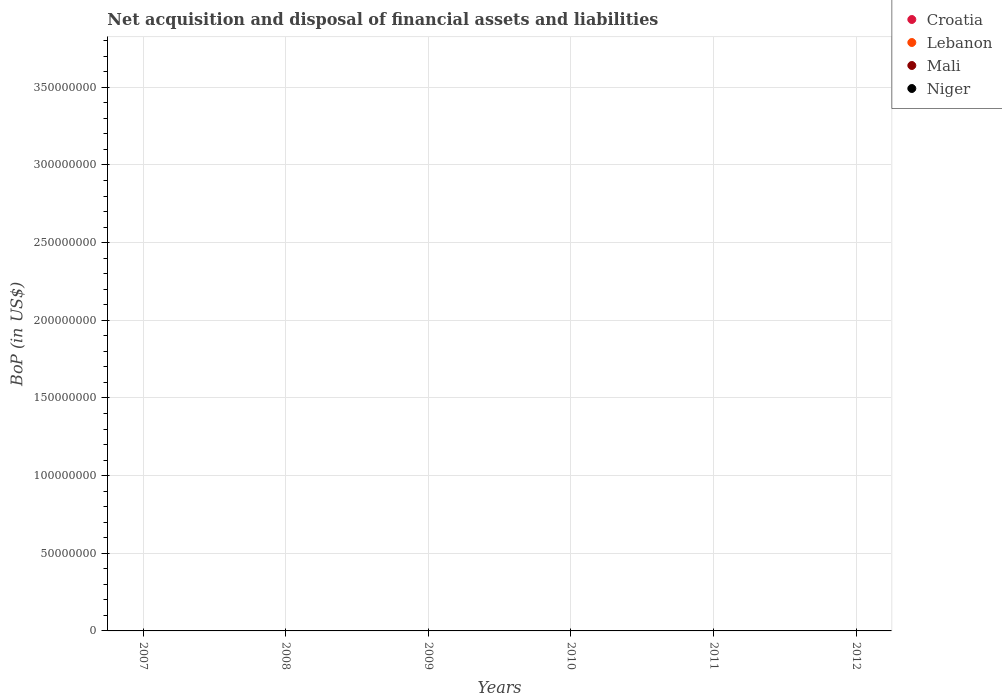How many different coloured dotlines are there?
Offer a very short reply. 0. What is the Balance of Payments in Niger in 2012?
Your answer should be compact. 0. What is the difference between the Balance of Payments in Lebanon in 2011 and the Balance of Payments in Mali in 2010?
Ensure brevity in your answer.  0. What is the average Balance of Payments in Croatia per year?
Your response must be concise. 0. Is it the case that in every year, the sum of the Balance of Payments in Croatia and Balance of Payments in Lebanon  is greater than the Balance of Payments in Niger?
Your answer should be very brief. No. Is the Balance of Payments in Mali strictly greater than the Balance of Payments in Niger over the years?
Your response must be concise. No. Are the values on the major ticks of Y-axis written in scientific E-notation?
Ensure brevity in your answer.  No. Does the graph contain grids?
Offer a very short reply. Yes. How are the legend labels stacked?
Your response must be concise. Vertical. What is the title of the graph?
Make the answer very short. Net acquisition and disposal of financial assets and liabilities. Does "Dominica" appear as one of the legend labels in the graph?
Offer a very short reply. No. What is the label or title of the X-axis?
Your answer should be compact. Years. What is the label or title of the Y-axis?
Keep it short and to the point. BoP (in US$). What is the BoP (in US$) in Croatia in 2007?
Make the answer very short. 0. What is the BoP (in US$) of Lebanon in 2008?
Your answer should be compact. 0. What is the BoP (in US$) of Croatia in 2009?
Your answer should be very brief. 0. What is the BoP (in US$) of Mali in 2009?
Offer a very short reply. 0. What is the BoP (in US$) of Niger in 2009?
Keep it short and to the point. 0. What is the BoP (in US$) of Lebanon in 2010?
Your answer should be compact. 0. What is the BoP (in US$) in Mali in 2010?
Keep it short and to the point. 0. What is the BoP (in US$) of Niger in 2010?
Your answer should be compact. 0. What is the BoP (in US$) of Mali in 2011?
Provide a short and direct response. 0. What is the BoP (in US$) of Croatia in 2012?
Keep it short and to the point. 0. What is the BoP (in US$) in Lebanon in 2012?
Give a very brief answer. 0. What is the BoP (in US$) of Mali in 2012?
Your answer should be very brief. 0. What is the BoP (in US$) in Niger in 2012?
Ensure brevity in your answer.  0. What is the total BoP (in US$) of Lebanon in the graph?
Offer a terse response. 0. What is the total BoP (in US$) of Mali in the graph?
Offer a terse response. 0. What is the total BoP (in US$) of Niger in the graph?
Your answer should be very brief. 0. What is the average BoP (in US$) in Croatia per year?
Give a very brief answer. 0. 